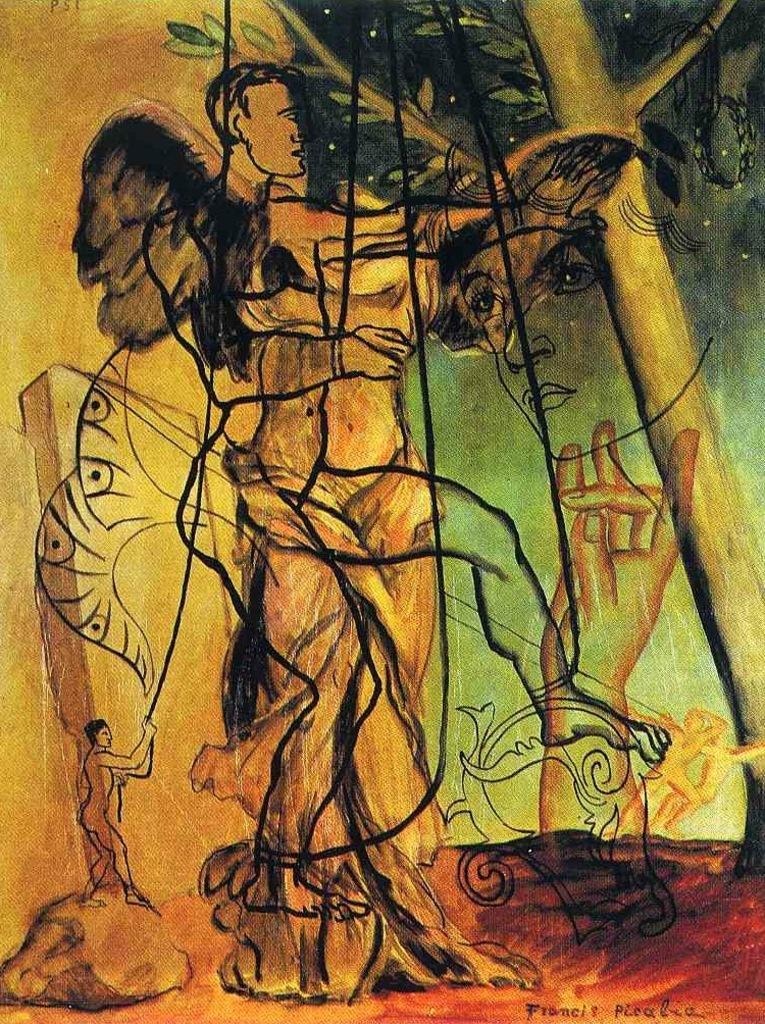How would you summarize this image in a sentence or two? In the image there are some paintings of human beings and other objects. 